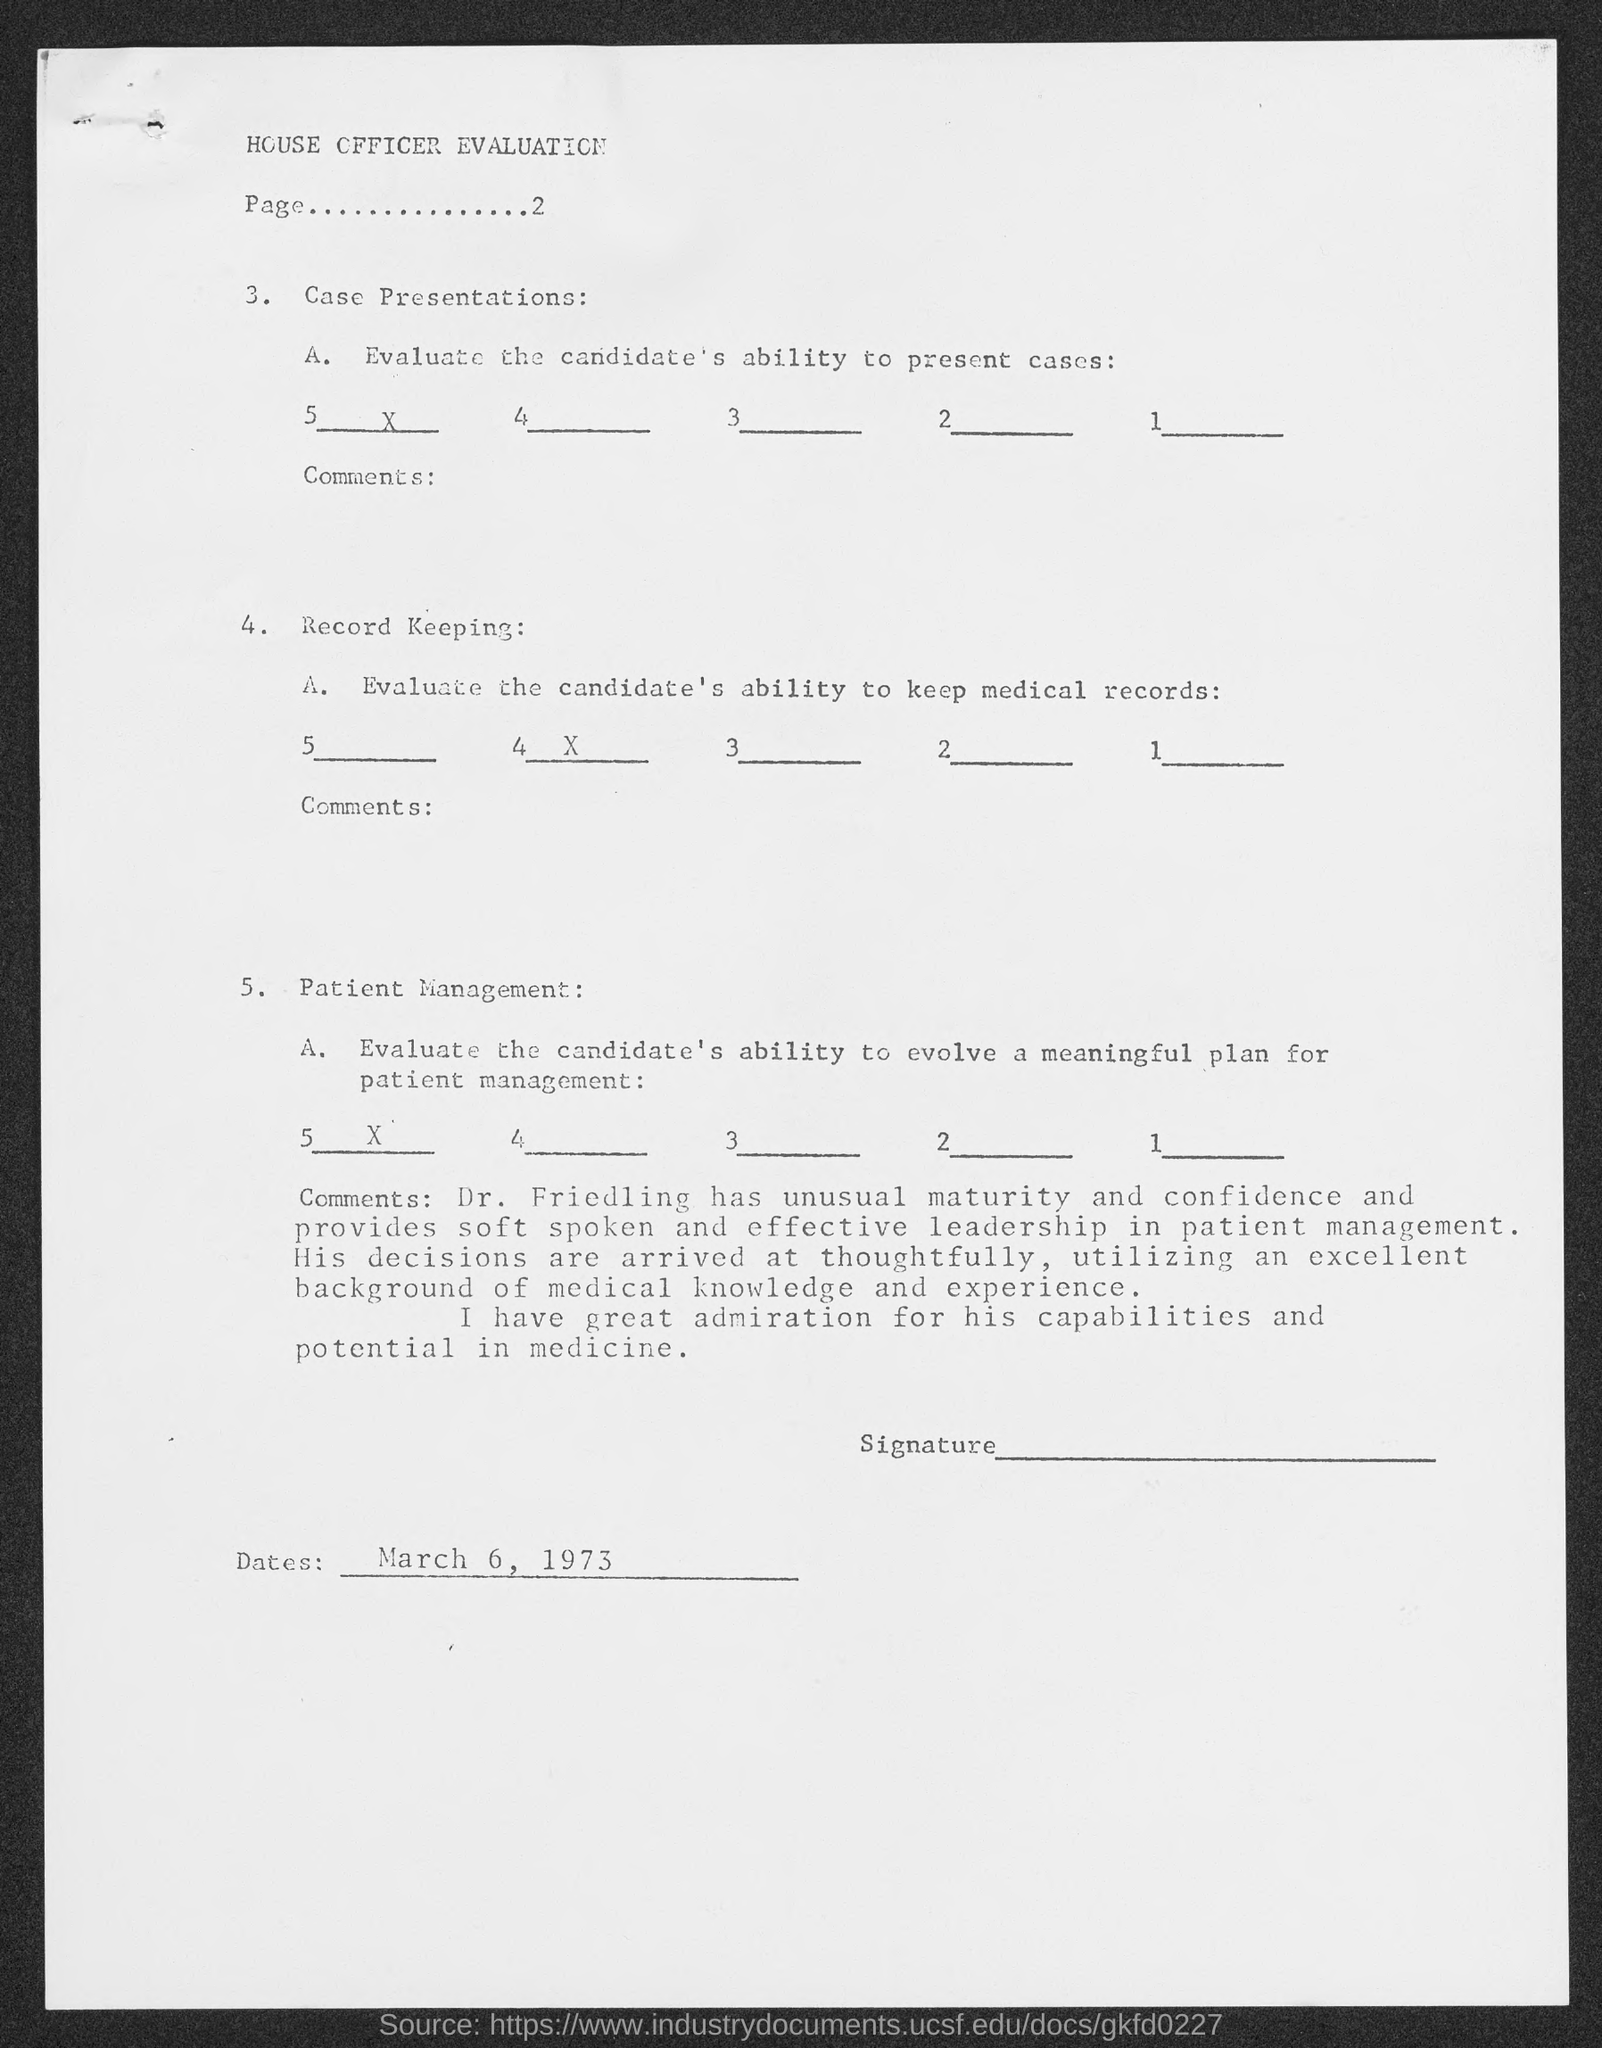List a handful of essential elements in this visual. The date mentioned in the given page is March 6, 1973. 